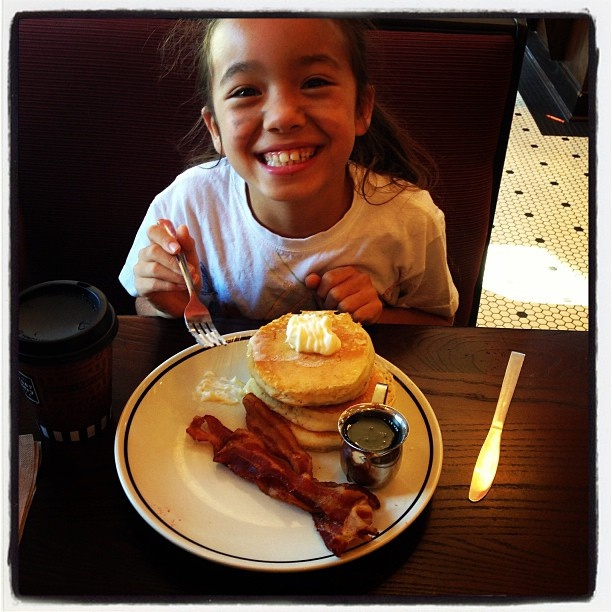Describe the objects in this image and their specific colors. I can see dining table in white, black, maroon, brown, and tan tones, people in white, maroon, brown, and black tones, cup in white, black, gray, and darkblue tones, cup in white, black, maroon, and brown tones, and knife in white, tan, lightyellow, and khaki tones in this image. 